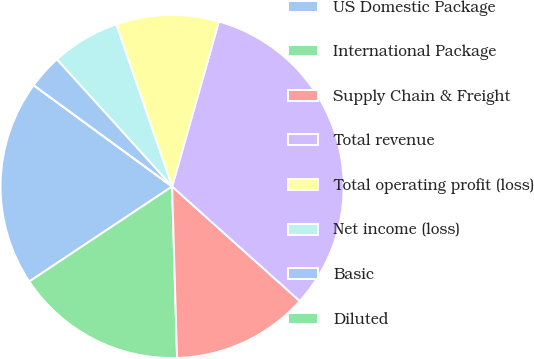Convert chart to OTSL. <chart><loc_0><loc_0><loc_500><loc_500><pie_chart><fcel>US Domestic Package<fcel>International Package<fcel>Supply Chain & Freight<fcel>Total revenue<fcel>Total operating profit (loss)<fcel>Net income (loss)<fcel>Basic<fcel>Diluted<nl><fcel>19.39%<fcel>16.12%<fcel>12.9%<fcel>32.24%<fcel>9.67%<fcel>6.45%<fcel>3.23%<fcel>0.0%<nl></chart> 